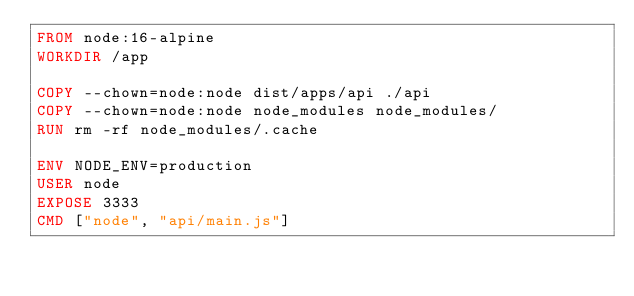<code> <loc_0><loc_0><loc_500><loc_500><_Dockerfile_>FROM node:16-alpine
WORKDIR /app

COPY --chown=node:node dist/apps/api ./api
COPY --chown=node:node node_modules node_modules/
RUN rm -rf node_modules/.cache

ENV NODE_ENV=production
USER node
EXPOSE 3333
CMD ["node", "api/main.js"]
</code> 